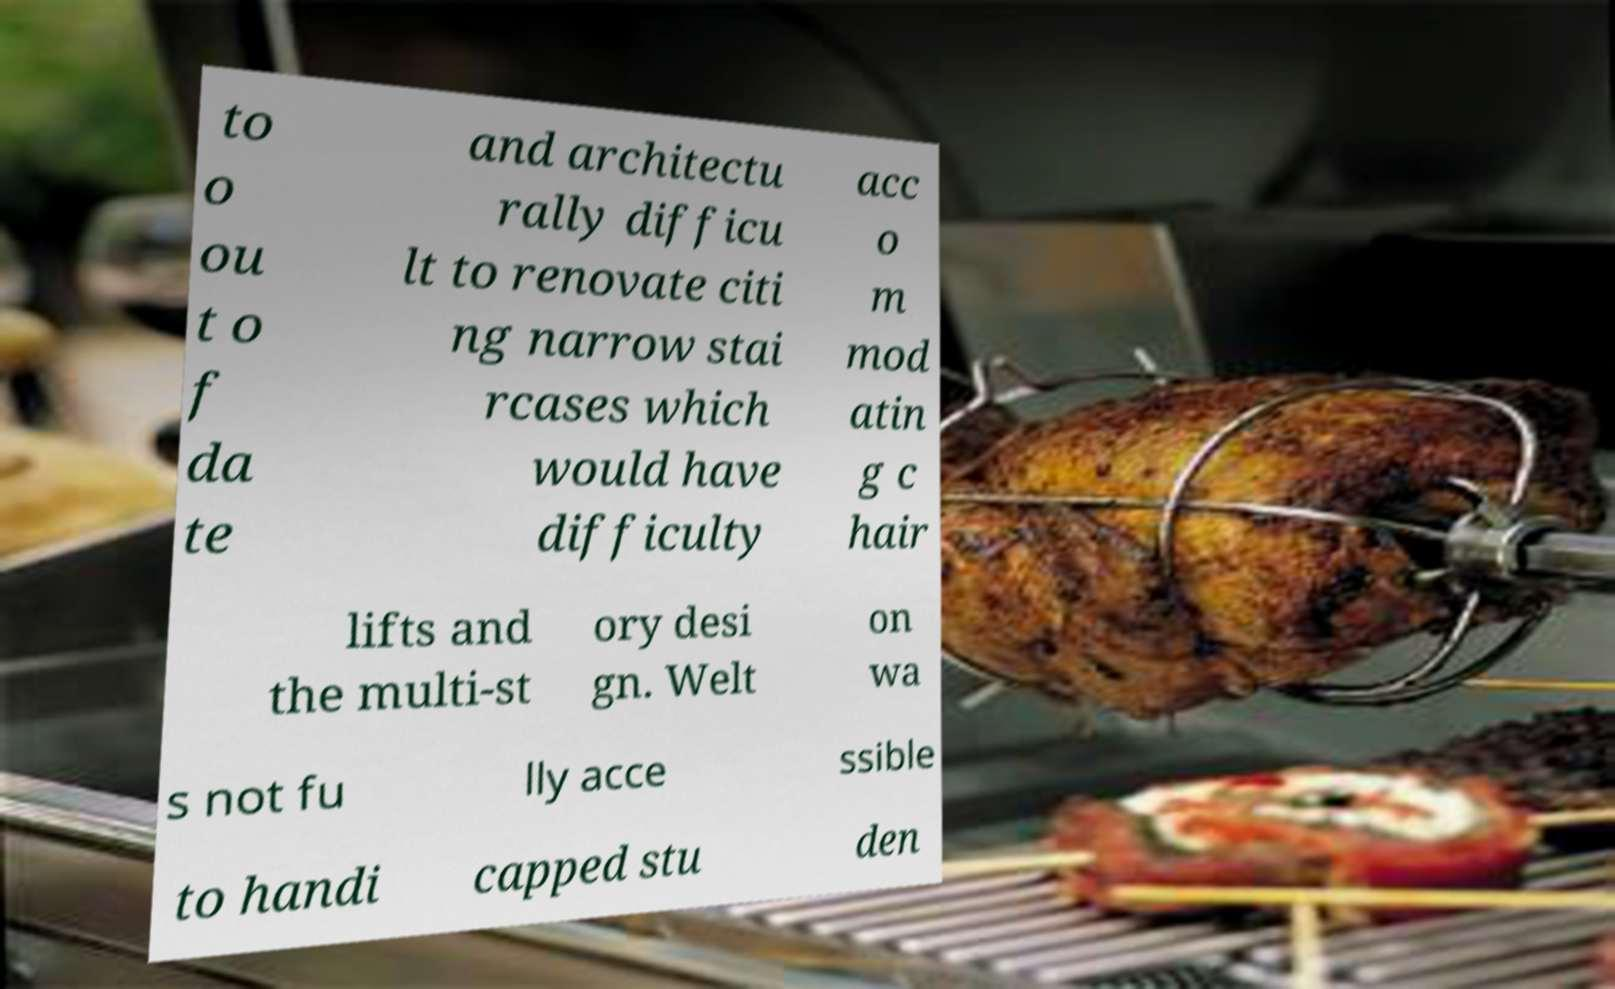Could you extract and type out the text from this image? to o ou t o f da te and architectu rally difficu lt to renovate citi ng narrow stai rcases which would have difficulty acc o m mod atin g c hair lifts and the multi-st ory desi gn. Welt on wa s not fu lly acce ssible to handi capped stu den 